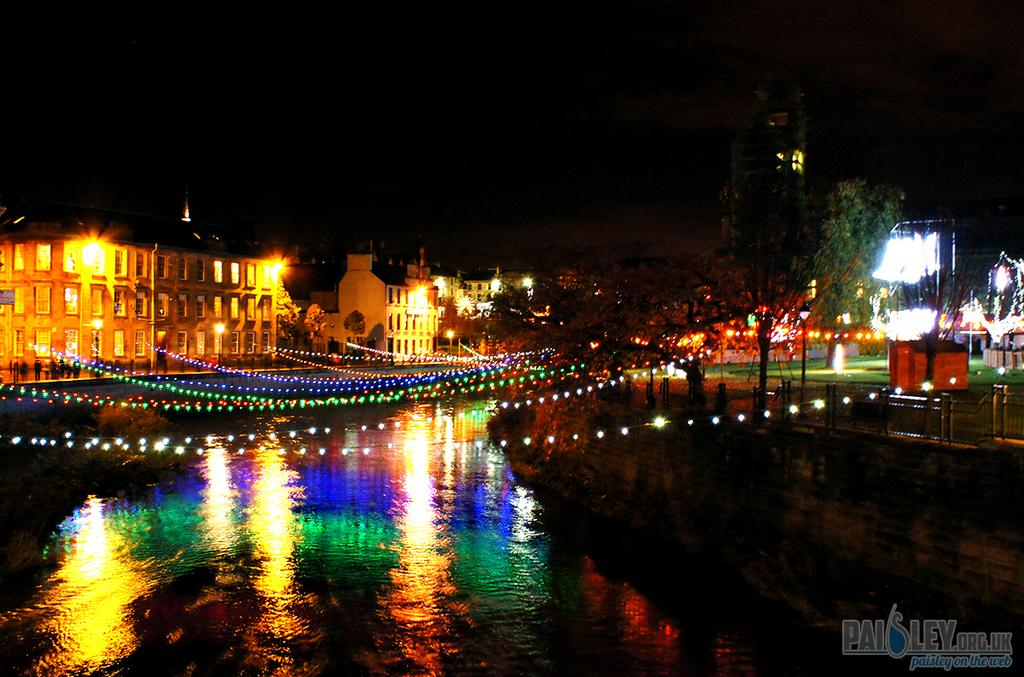What type of structures can be seen in the image? There are buildings in the image. What other natural elements are present in the image? There are trees in the image. How is the street in the image adorned? The street is decorated with lights. Where is the sheep located in the image? There is no sheep present in the image. Can you describe the spot where the friend is sitting in the image? There is no friend or specific spot mentioned in the image; it only features buildings, trees, and a decorated street. 